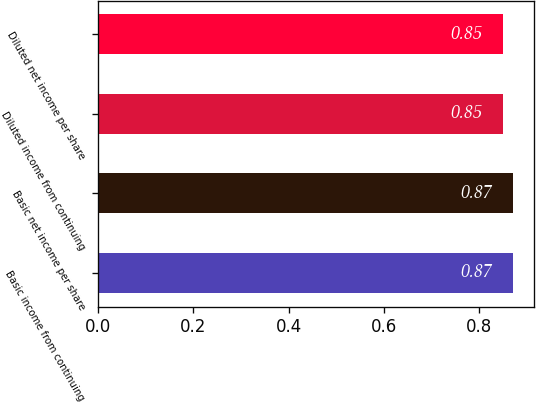Convert chart to OTSL. <chart><loc_0><loc_0><loc_500><loc_500><bar_chart><fcel>Basic income from continuing<fcel>Basic net income per share<fcel>Diluted income from continuing<fcel>Diluted net income per share<nl><fcel>0.87<fcel>0.87<fcel>0.85<fcel>0.85<nl></chart> 